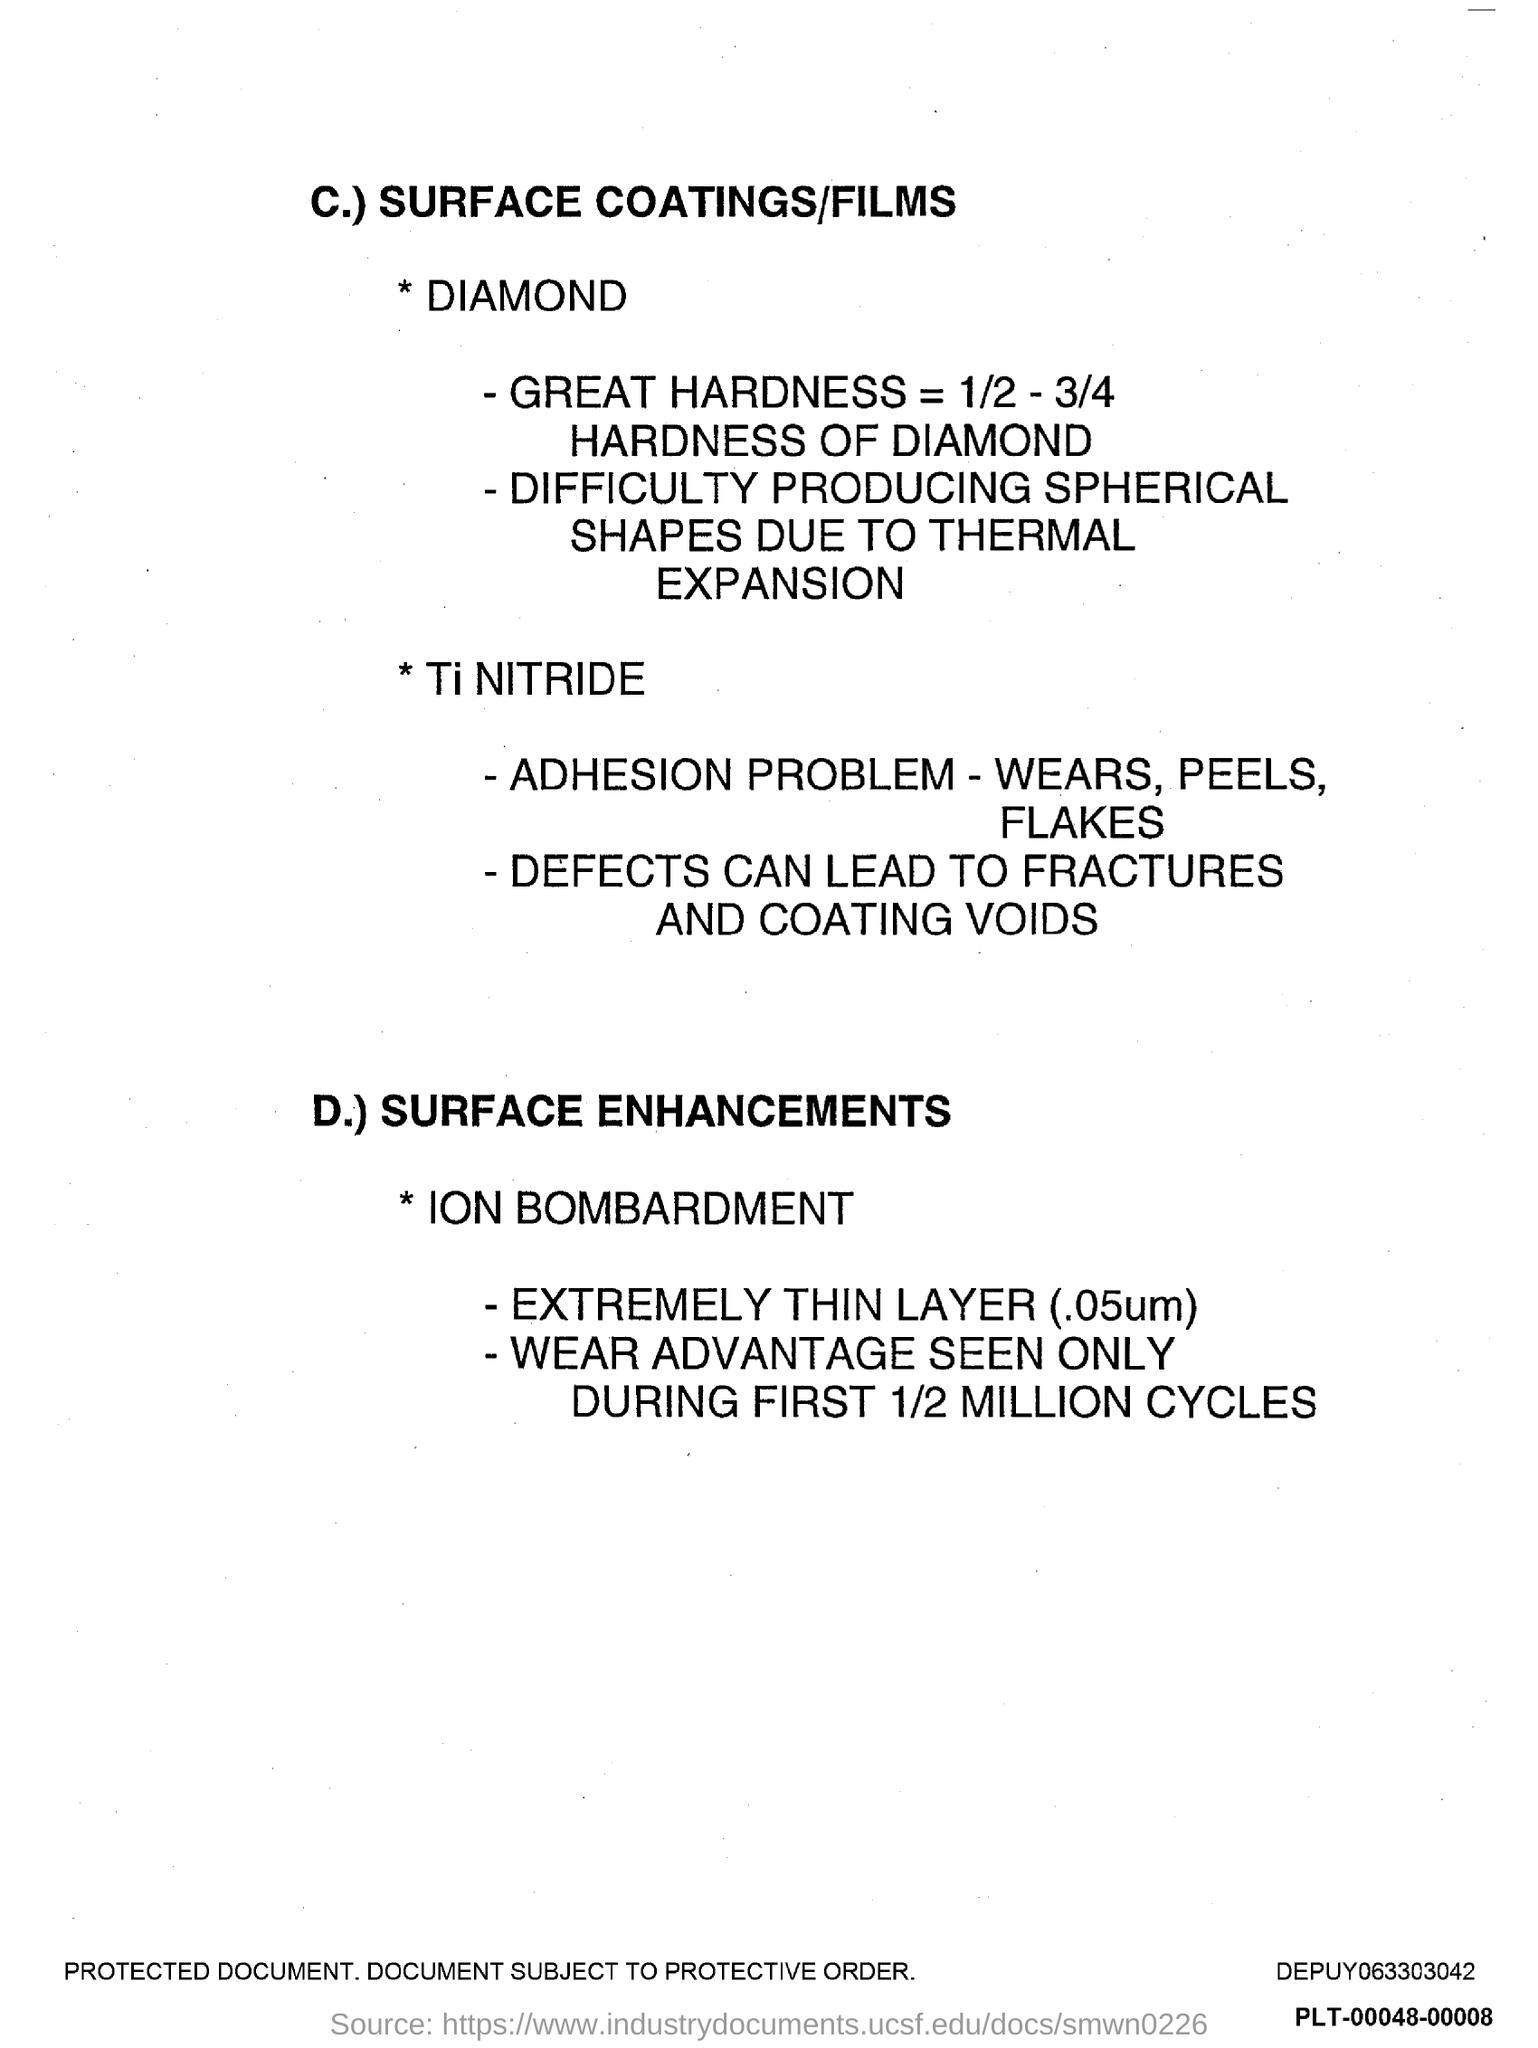What is the first title in the document?
Keep it short and to the point. SURFACE COATINGS/FILMS. 